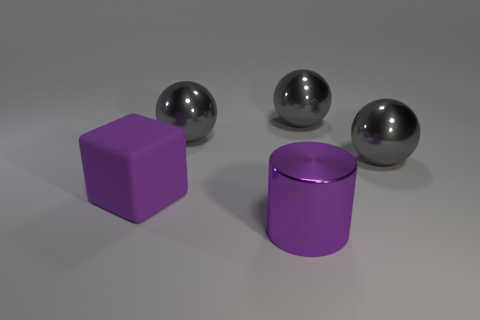Add 2 brown cylinders. How many objects exist? 7 Subtract all cubes. How many objects are left? 4 Subtract all red spheres. Subtract all brown cubes. How many spheres are left? 3 Subtract all large gray metallic balls. Subtract all blocks. How many objects are left? 1 Add 2 purple shiny things. How many purple shiny things are left? 3 Add 1 purple shiny cylinders. How many purple shiny cylinders exist? 2 Subtract 0 brown blocks. How many objects are left? 5 